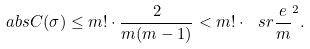<formula> <loc_0><loc_0><loc_500><loc_500>\ a b s { C ( \sigma ) } \leq m ! \cdot \frac { 2 } { m ( m - 1 ) } < m ! \cdot \ s r { \frac { e } { m } } ^ { 2 } .</formula> 